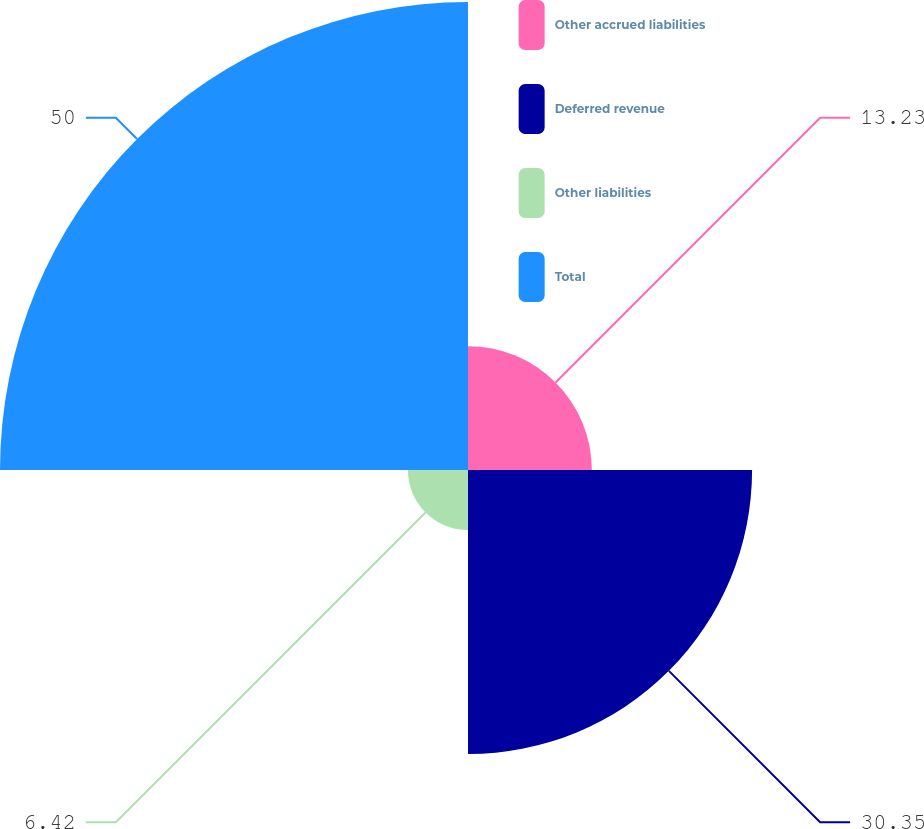Convert chart to OTSL. <chart><loc_0><loc_0><loc_500><loc_500><pie_chart><fcel>Other accrued liabilities<fcel>Deferred revenue<fcel>Other liabilities<fcel>Total<nl><fcel>13.23%<fcel>30.35%<fcel>6.42%<fcel>50.0%<nl></chart> 